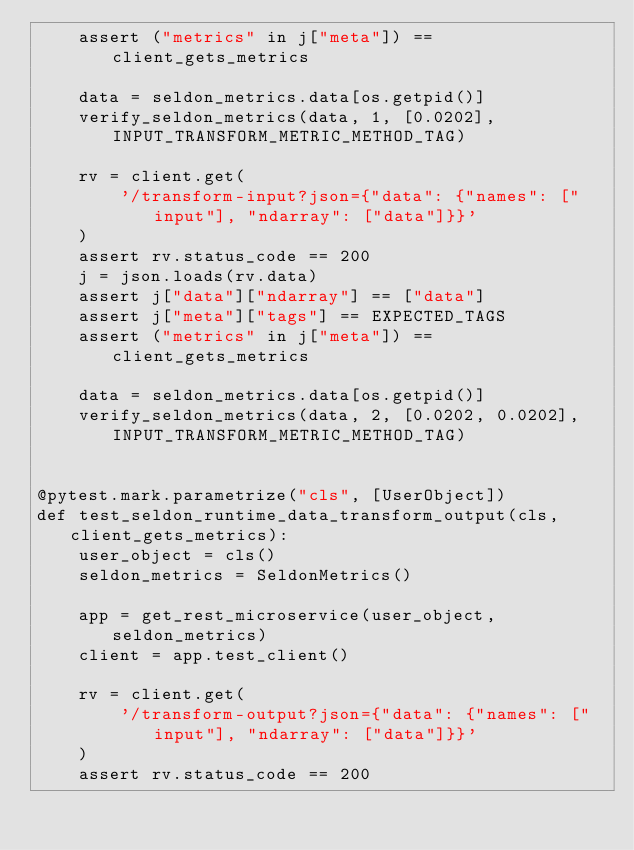<code> <loc_0><loc_0><loc_500><loc_500><_Python_>    assert ("metrics" in j["meta"]) == client_gets_metrics

    data = seldon_metrics.data[os.getpid()]
    verify_seldon_metrics(data, 1, [0.0202], INPUT_TRANSFORM_METRIC_METHOD_TAG)

    rv = client.get(
        '/transform-input?json={"data": {"names": ["input"], "ndarray": ["data"]}}'
    )
    assert rv.status_code == 200
    j = json.loads(rv.data)
    assert j["data"]["ndarray"] == ["data"]
    assert j["meta"]["tags"] == EXPECTED_TAGS
    assert ("metrics" in j["meta"]) == client_gets_metrics

    data = seldon_metrics.data[os.getpid()]
    verify_seldon_metrics(data, 2, [0.0202, 0.0202], INPUT_TRANSFORM_METRIC_METHOD_TAG)


@pytest.mark.parametrize("cls", [UserObject])
def test_seldon_runtime_data_transform_output(cls, client_gets_metrics):
    user_object = cls()
    seldon_metrics = SeldonMetrics()

    app = get_rest_microservice(user_object, seldon_metrics)
    client = app.test_client()

    rv = client.get(
        '/transform-output?json={"data": {"names": ["input"], "ndarray": ["data"]}}'
    )
    assert rv.status_code == 200</code> 